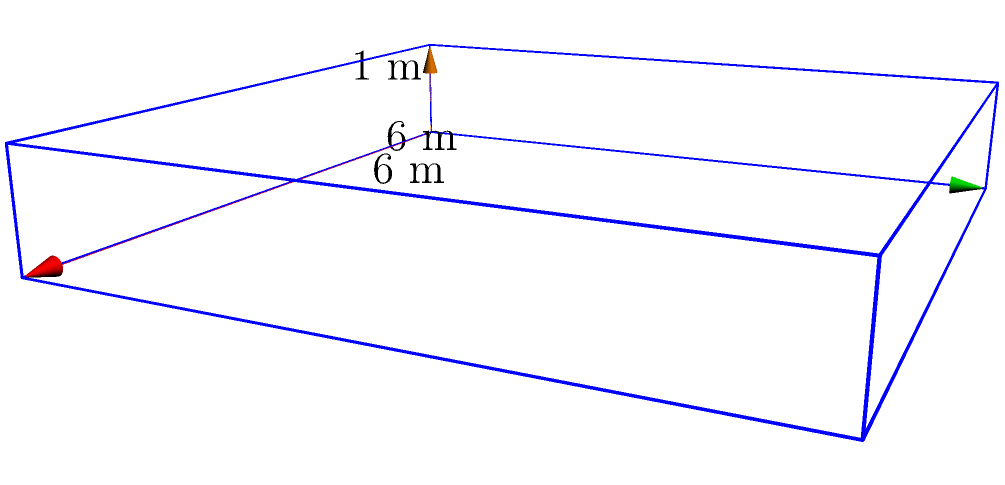As a filmmaker documenting a retired fighter's career, you're recreating a famous boxing ring for a scene. The ring is represented as a rectangular prism with dimensions 6 m x 6 m x 1 m (length x width x height). What is the volume of this boxing ring in cubic meters? To calculate the volume of a rectangular prism, we use the formula:

$$ V = l \times w \times h $$

Where:
$V$ = volume
$l$ = length
$w$ = width
$h$ = height

Given dimensions:
Length ($l$) = 6 m
Width ($w$) = 6 m
Height ($h$) = 1 m

Substituting these values into the formula:

$$ V = 6 \text{ m} \times 6 \text{ m} \times 1 \text{ m} $$

$$ V = 36 \text{ m}^3 $$

Therefore, the volume of the boxing ring is 36 cubic meters.
Answer: 36 m³ 